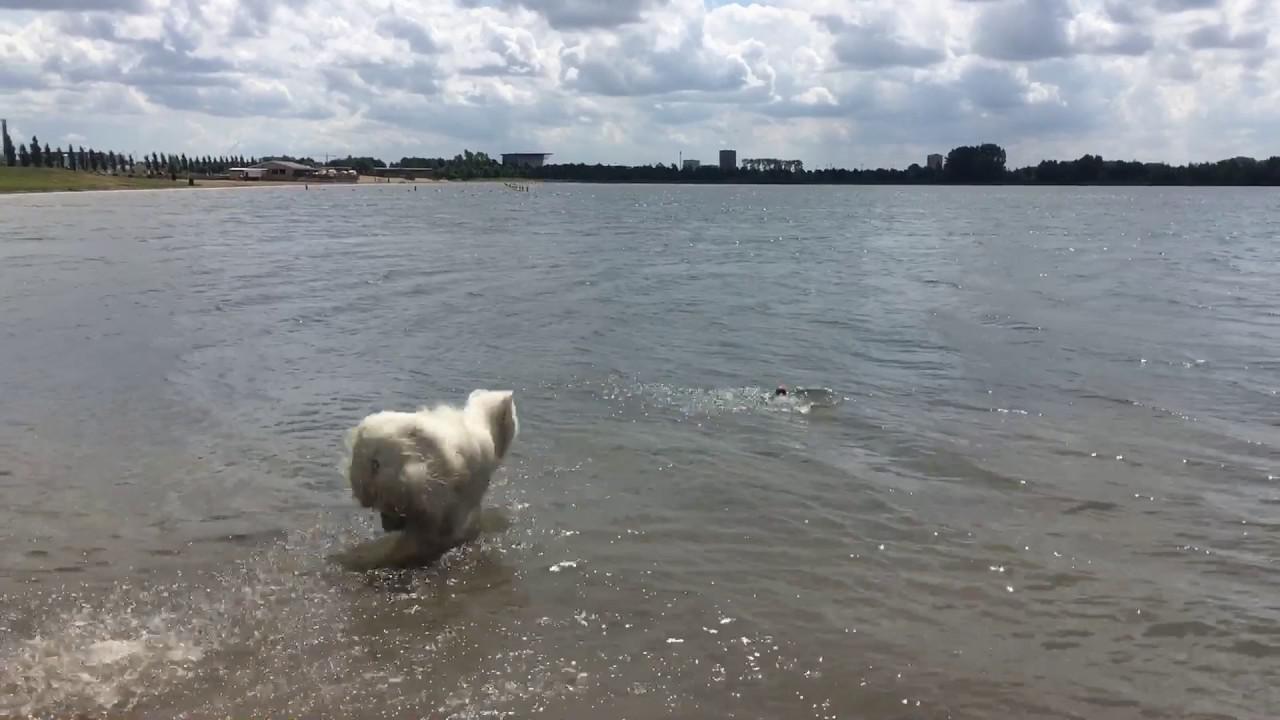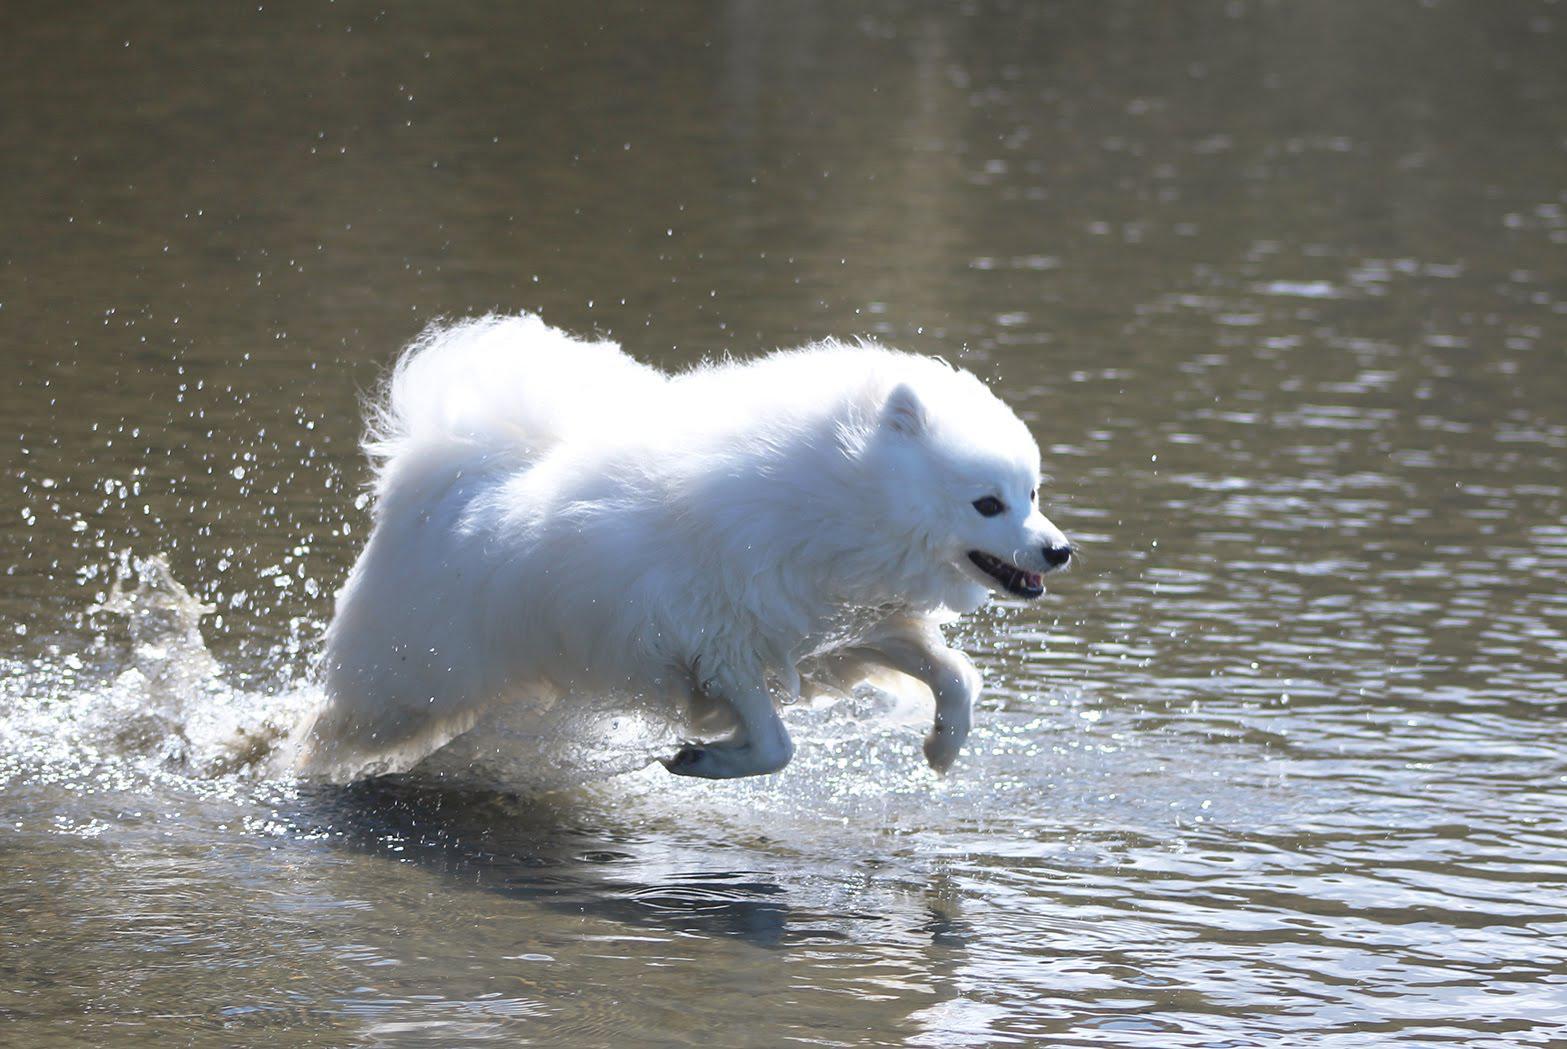The first image is the image on the left, the second image is the image on the right. Given the left and right images, does the statement "There is at least one dog that is not playing or swimming in the water." hold true? Answer yes or no. No. The first image is the image on the left, the second image is the image on the right. For the images displayed, is the sentence "The dog in the left image is standing on the ground; he is not in the water." factually correct? Answer yes or no. No. 